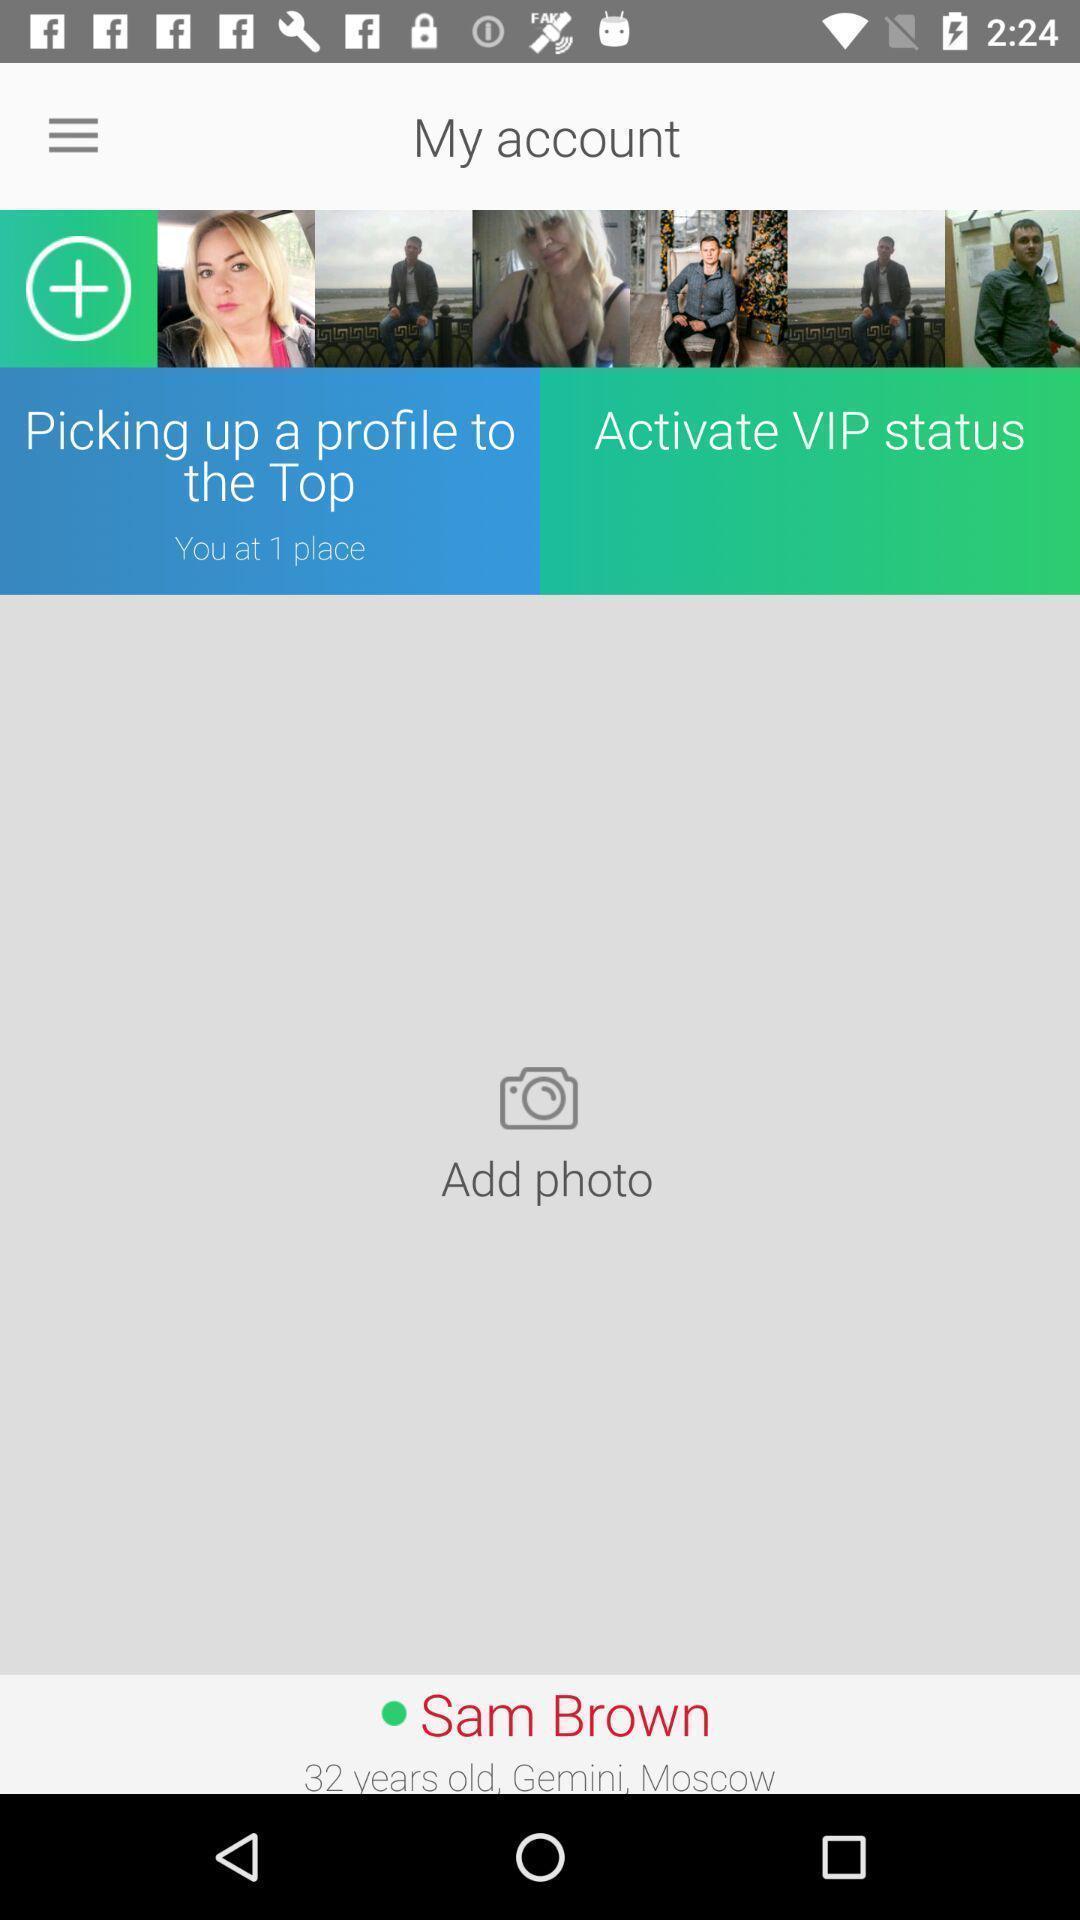Provide a detailed account of this screenshot. Page to add a photo in a social app. 